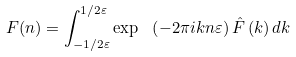<formula> <loc_0><loc_0><loc_500><loc_500>F ( n ) = \int _ { - 1 / 2 \varepsilon } ^ { 1 / 2 \varepsilon } \exp \ \left ( { - 2 \pi i k n \varepsilon } \right ) \hat { F } \left ( { k } \right ) d k</formula> 